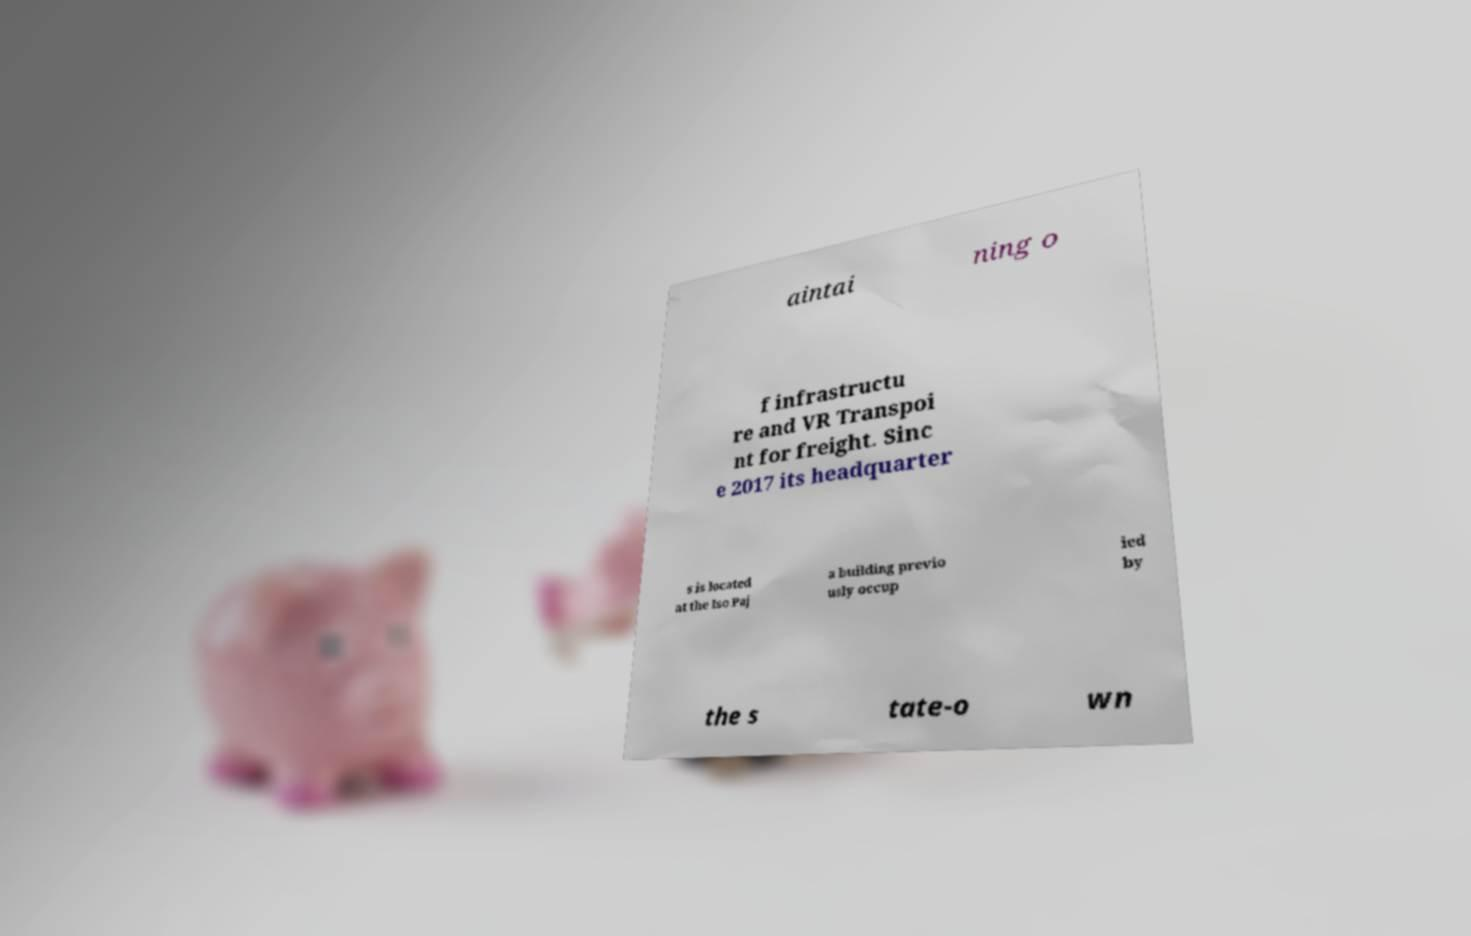Can you accurately transcribe the text from the provided image for me? aintai ning o f infrastructu re and VR Transpoi nt for freight. Sinc e 2017 its headquarter s is located at the Iso Paj a building previo usly occup ied by the s tate-o wn 